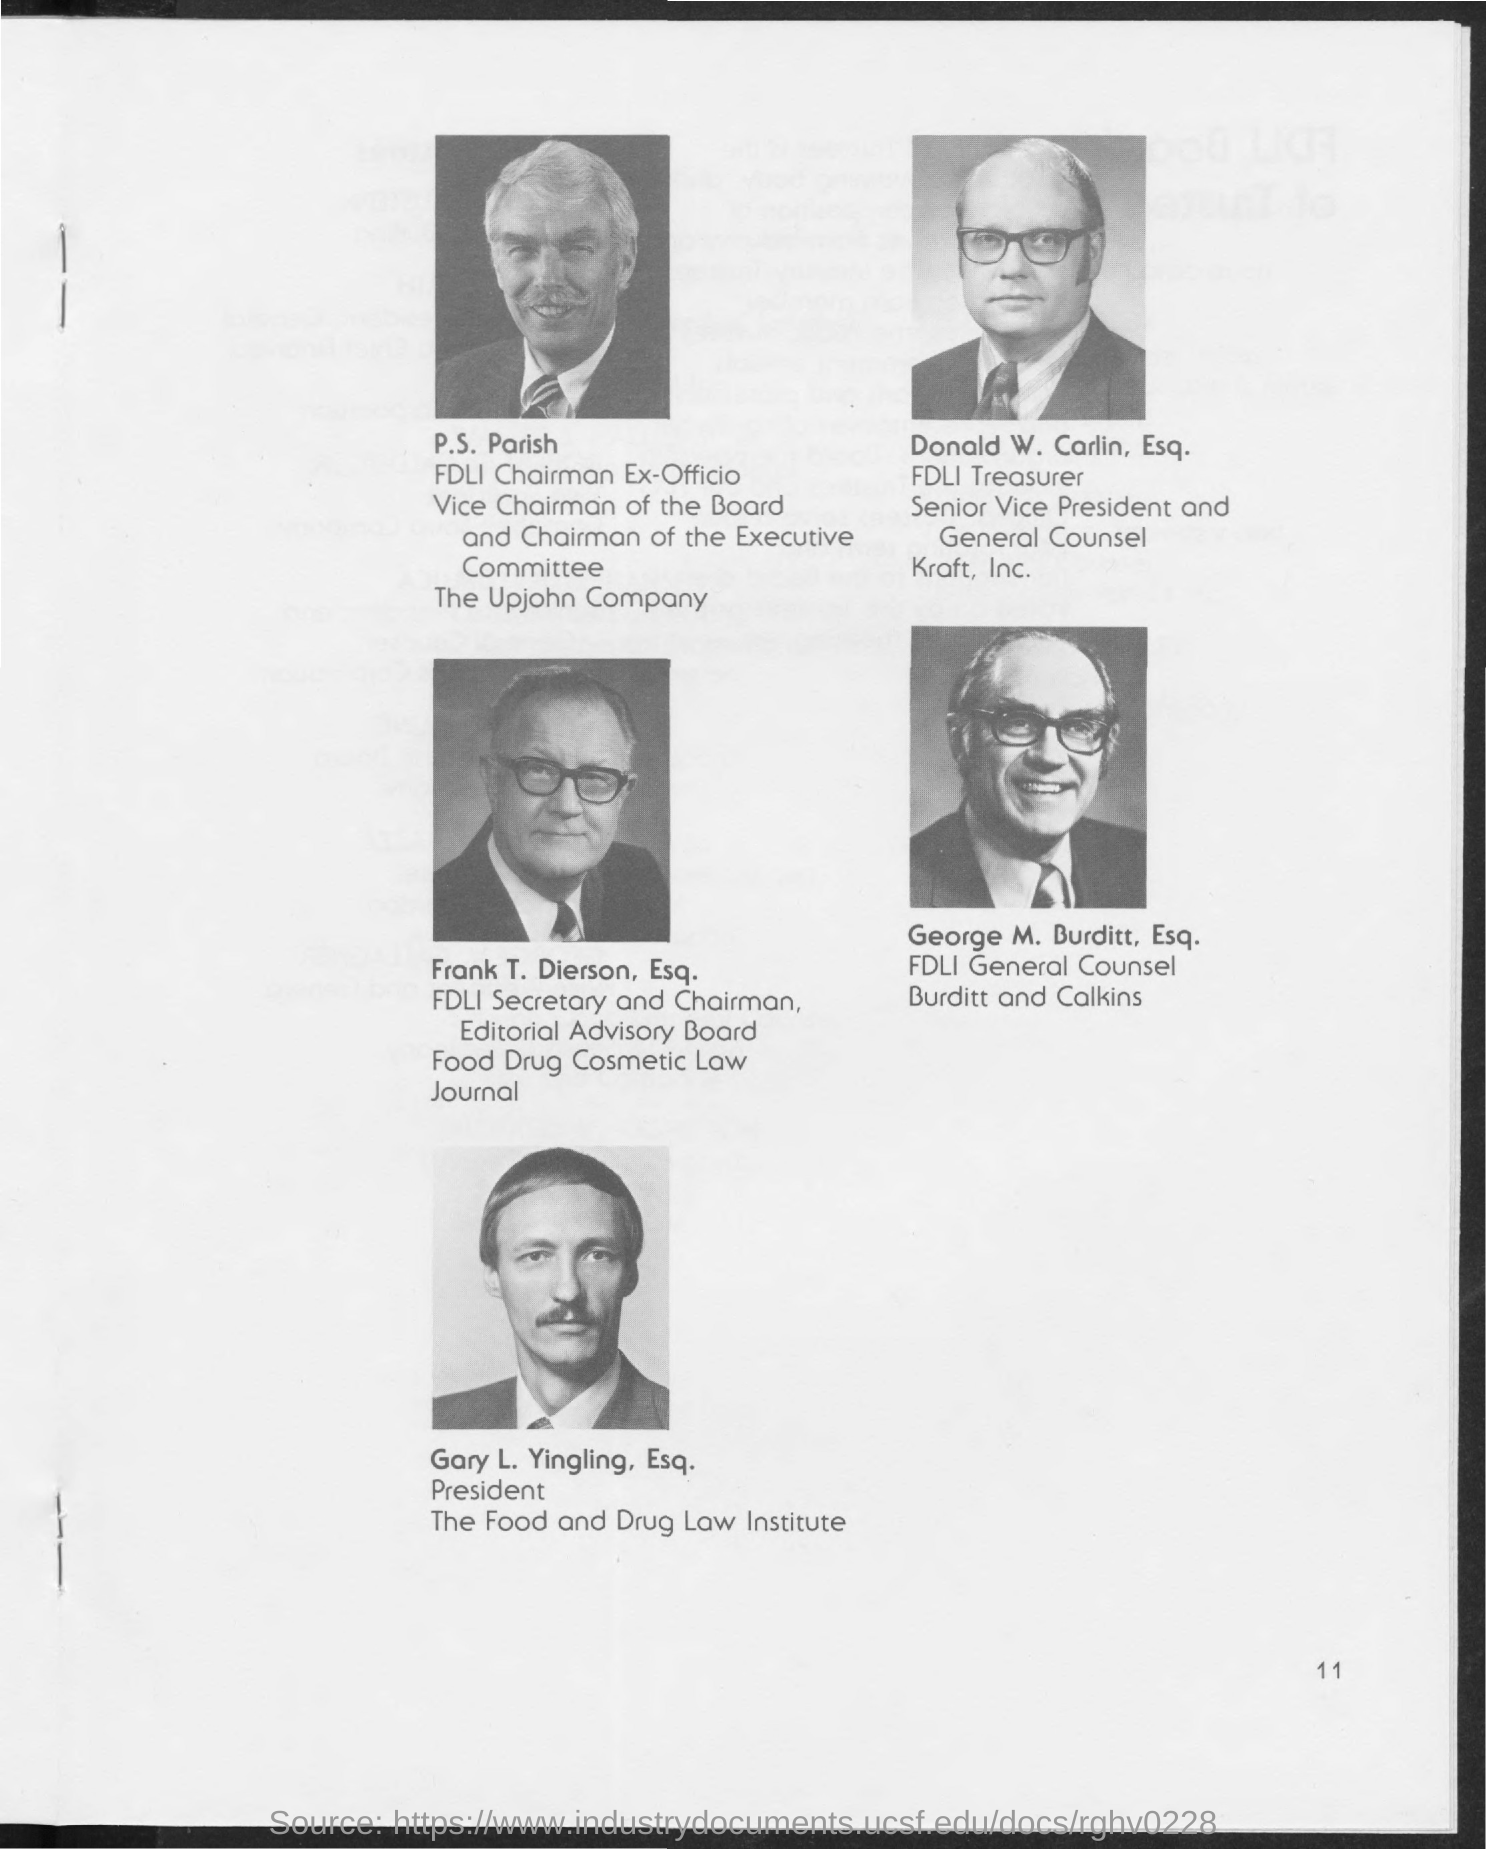Who is the fdli general counsel burditt and calkins
Offer a very short reply. George M. Burditt, Esq. Who is the fdli secretary and chairman
Provide a succinct answer. Frank T. Dierson Esq. Who is the fdli treasurer ?
Provide a succinct answer. Donald w. Carlin Esq. Who is the fdli chairman ex - officio
Make the answer very short. P.S. Parish. 